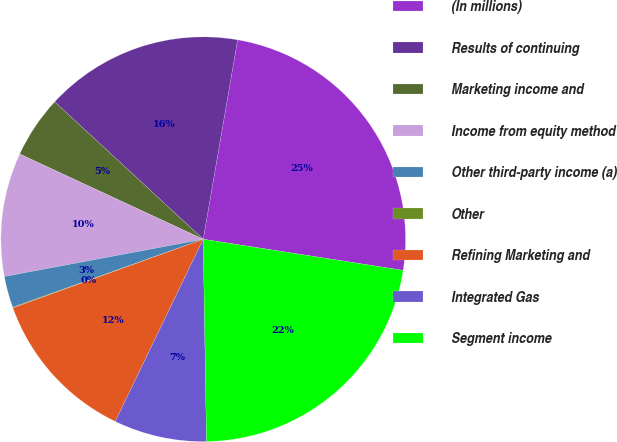<chart> <loc_0><loc_0><loc_500><loc_500><pie_chart><fcel>(In millions)<fcel>Results of continuing<fcel>Marketing income and<fcel>Income from equity method<fcel>Other third-party income (a)<fcel>Other<fcel>Refining Marketing and<fcel>Integrated Gas<fcel>Segment income<nl><fcel>24.74%<fcel>15.84%<fcel>4.96%<fcel>9.87%<fcel>2.51%<fcel>0.05%<fcel>12.33%<fcel>7.42%<fcel>22.28%<nl></chart> 